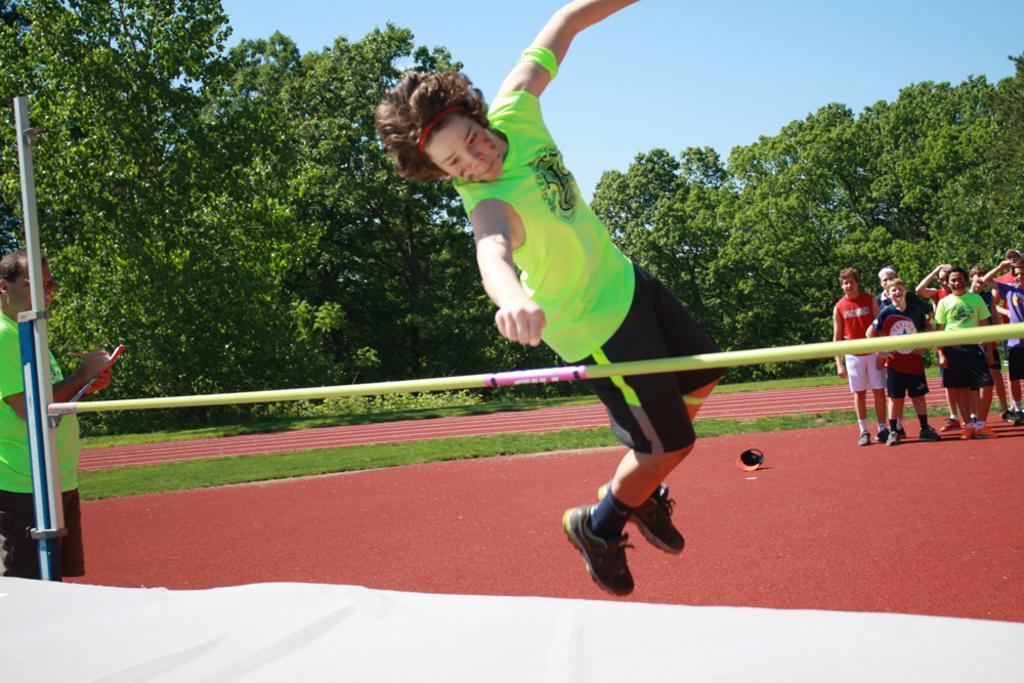Can you describe this image briefly? In this picture, we see a boy is jumping. In front of him, we see a pole. At the bottom, it is white in color. On the left side, we see a man is standing and he is holding a pen and a book in his hands. On the right side, we see the boys are standing. In the middle, we see the grass. There are trees in the background. At the top, we see the sky. 